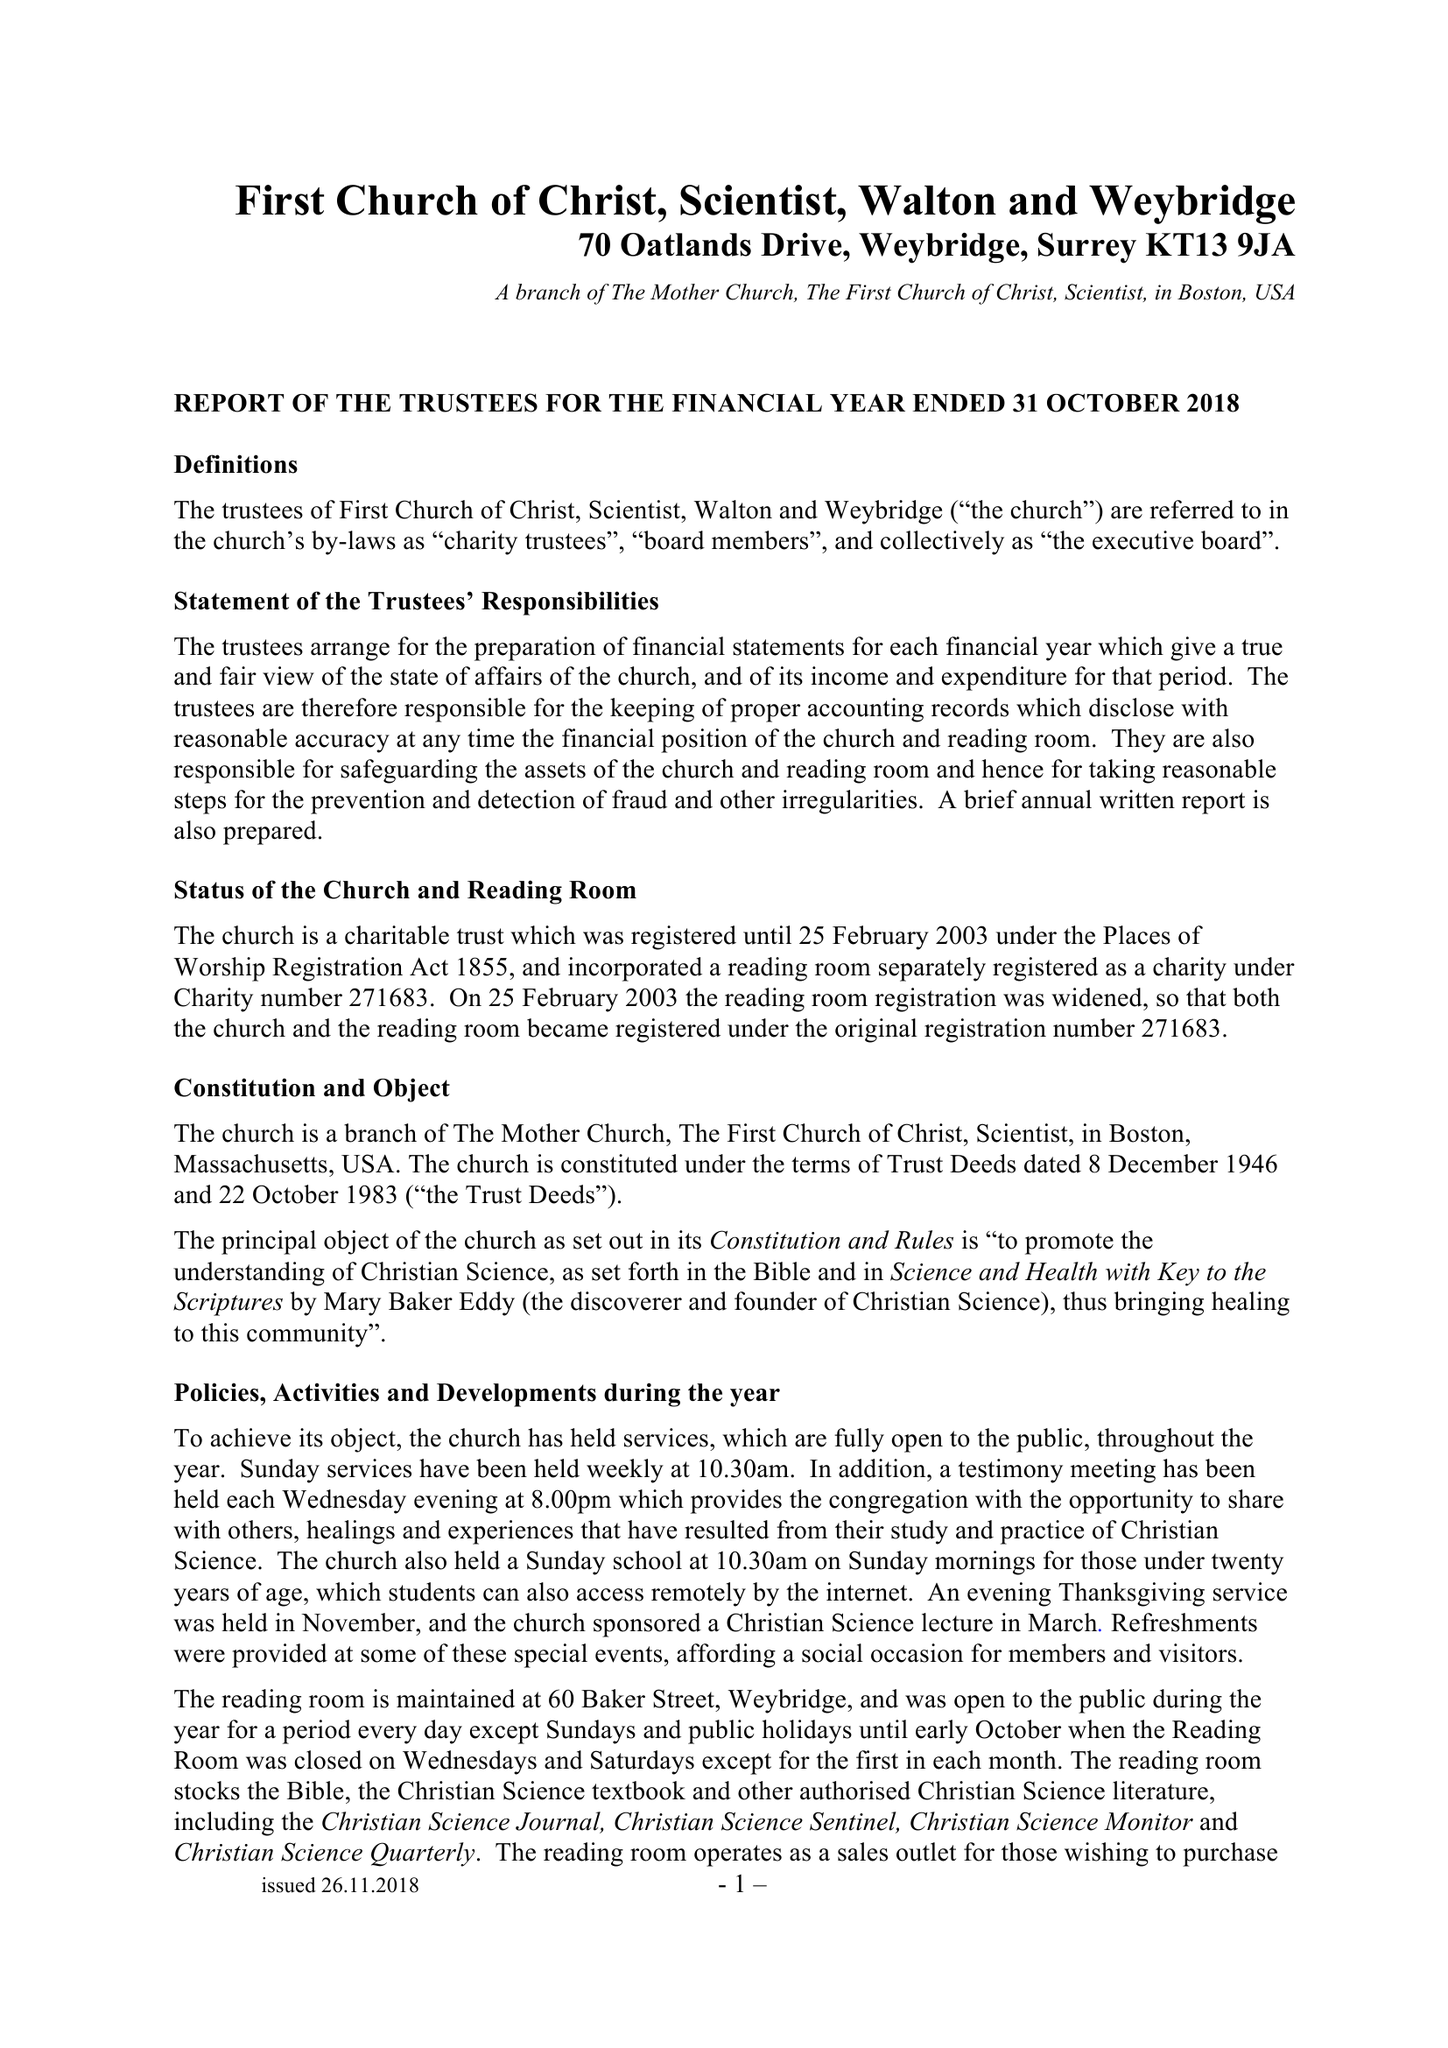What is the value for the address__street_line?
Answer the question using a single word or phrase. 70 OATLANDS DRIVE 